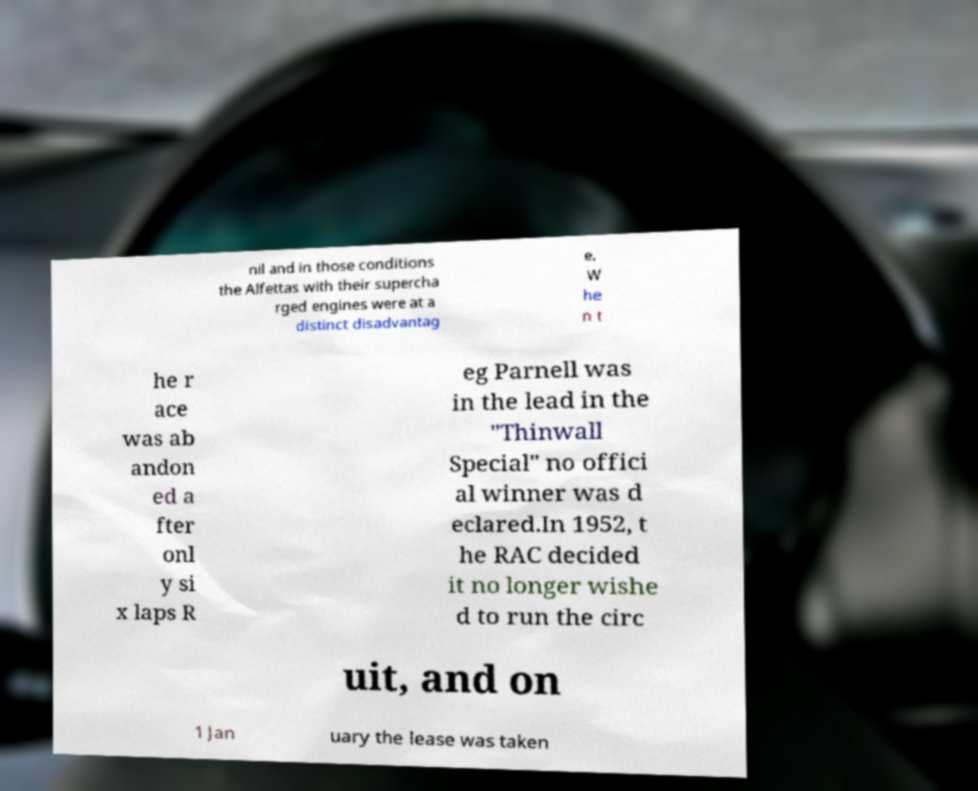What messages or text are displayed in this image? I need them in a readable, typed format. nil and in those conditions the Alfettas with their supercha rged engines were at a distinct disadvantag e. W he n t he r ace was ab andon ed a fter onl y si x laps R eg Parnell was in the lead in the "Thinwall Special" no offici al winner was d eclared.In 1952, t he RAC decided it no longer wishe d to run the circ uit, and on 1 Jan uary the lease was taken 